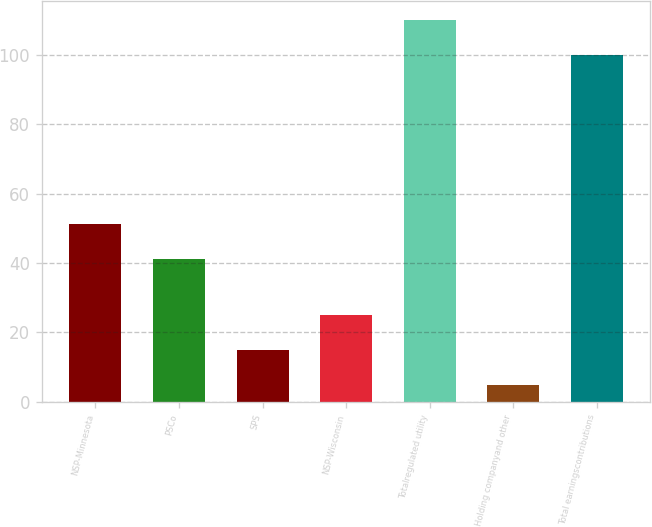Convert chart. <chart><loc_0><loc_0><loc_500><loc_500><bar_chart><fcel>NSP-Minnesota<fcel>PSCo<fcel>SPS<fcel>NSP-Wisconsin<fcel>Totalregulated utility<fcel>Holding companyand other<fcel>Total earningscontributions<nl><fcel>51.3<fcel>41.3<fcel>14.9<fcel>24.9<fcel>110<fcel>4.9<fcel>100<nl></chart> 